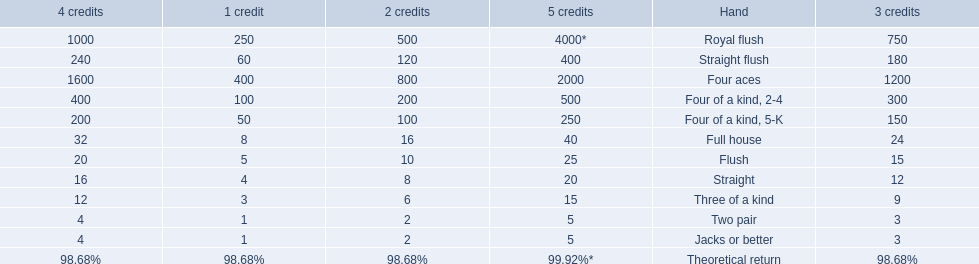What are the different hands? Royal flush, Straight flush, Four aces, Four of a kind, 2-4, Four of a kind, 5-K, Full house, Flush, Straight, Three of a kind, Two pair, Jacks or better. Which hands have a higher standing than a straight? Royal flush, Straight flush, Four aces, Four of a kind, 2-4, Four of a kind, 5-K, Full house, Flush. Of these, which hand is the next highest after a straight? Flush. 